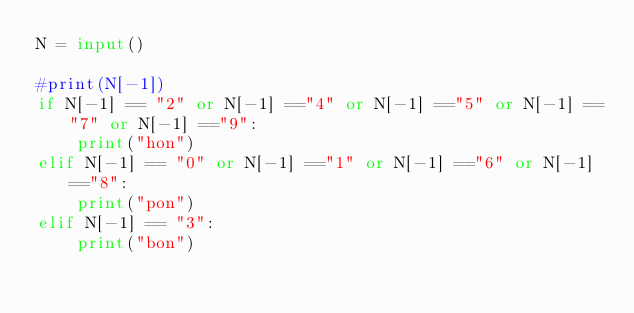<code> <loc_0><loc_0><loc_500><loc_500><_Python_>N = input()

#print(N[-1])
if N[-1] == "2" or N[-1] =="4" or N[-1] =="5" or N[-1] =="7" or N[-1] =="9":
    print("hon")
elif N[-1] == "0" or N[-1] =="1" or N[-1] =="6" or N[-1] =="8":
    print("pon")
elif N[-1] == "3":
    print("bon")</code> 